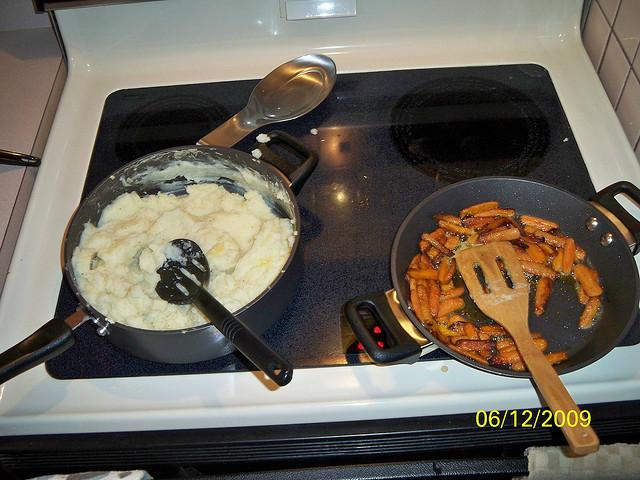What is the silver object above the mashed potatoes pan used for? spoon rest 